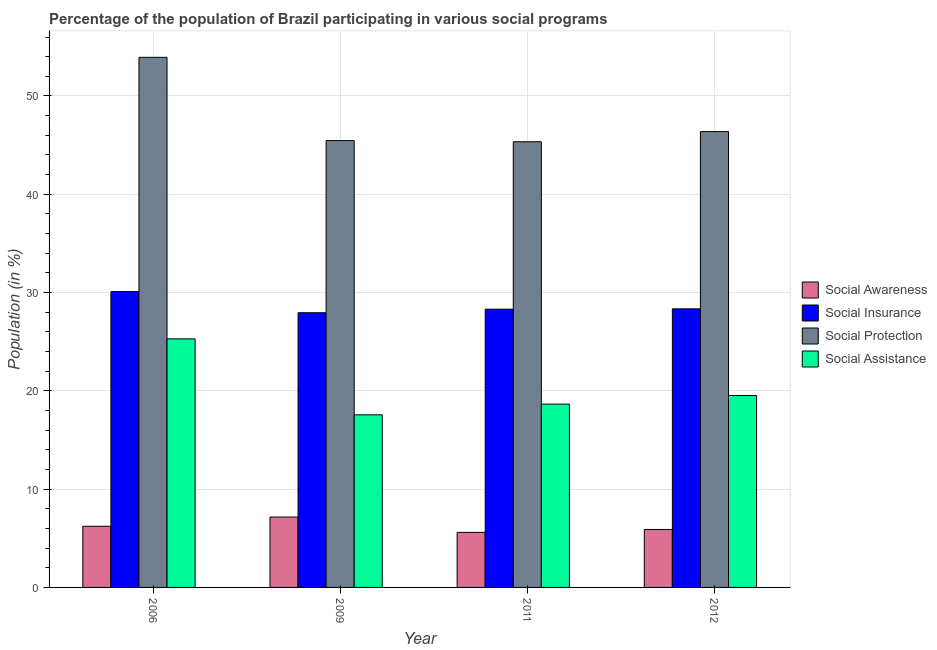Are the number of bars per tick equal to the number of legend labels?
Make the answer very short. Yes. How many bars are there on the 2nd tick from the left?
Your answer should be compact. 4. How many bars are there on the 3rd tick from the right?
Your answer should be very brief. 4. What is the participation of population in social assistance programs in 2011?
Offer a terse response. 18.65. Across all years, what is the maximum participation of population in social awareness programs?
Offer a very short reply. 7.16. Across all years, what is the minimum participation of population in social insurance programs?
Provide a succinct answer. 27.95. In which year was the participation of population in social insurance programs maximum?
Your answer should be compact. 2006. In which year was the participation of population in social insurance programs minimum?
Provide a succinct answer. 2009. What is the total participation of population in social assistance programs in the graph?
Offer a very short reply. 81.03. What is the difference between the participation of population in social protection programs in 2006 and that in 2009?
Provide a short and direct response. 8.47. What is the difference between the participation of population in social awareness programs in 2011 and the participation of population in social insurance programs in 2006?
Your answer should be very brief. -0.62. What is the average participation of population in social insurance programs per year?
Offer a terse response. 28.68. In the year 2012, what is the difference between the participation of population in social insurance programs and participation of population in social awareness programs?
Your answer should be very brief. 0. What is the ratio of the participation of population in social awareness programs in 2006 to that in 2009?
Provide a succinct answer. 0.87. Is the difference between the participation of population in social insurance programs in 2009 and 2011 greater than the difference between the participation of population in social awareness programs in 2009 and 2011?
Your answer should be very brief. No. What is the difference between the highest and the second highest participation of population in social assistance programs?
Make the answer very short. 5.76. What is the difference between the highest and the lowest participation of population in social assistance programs?
Provide a succinct answer. 7.73. In how many years, is the participation of population in social insurance programs greater than the average participation of population in social insurance programs taken over all years?
Make the answer very short. 1. Is it the case that in every year, the sum of the participation of population in social assistance programs and participation of population in social protection programs is greater than the sum of participation of population in social insurance programs and participation of population in social awareness programs?
Provide a succinct answer. No. What does the 4th bar from the left in 2006 represents?
Give a very brief answer. Social Assistance. What does the 3rd bar from the right in 2009 represents?
Make the answer very short. Social Insurance. Is it the case that in every year, the sum of the participation of population in social awareness programs and participation of population in social insurance programs is greater than the participation of population in social protection programs?
Make the answer very short. No. What is the difference between two consecutive major ticks on the Y-axis?
Provide a short and direct response. 10. Are the values on the major ticks of Y-axis written in scientific E-notation?
Provide a succinct answer. No. Does the graph contain any zero values?
Ensure brevity in your answer.  No. Where does the legend appear in the graph?
Ensure brevity in your answer.  Center right. What is the title of the graph?
Offer a terse response. Percentage of the population of Brazil participating in various social programs . What is the label or title of the Y-axis?
Ensure brevity in your answer.  Population (in %). What is the Population (in %) of Social Awareness in 2006?
Offer a terse response. 6.22. What is the Population (in %) in Social Insurance in 2006?
Offer a terse response. 30.1. What is the Population (in %) of Social Protection in 2006?
Your response must be concise. 53.93. What is the Population (in %) in Social Assistance in 2006?
Your answer should be compact. 25.29. What is the Population (in %) in Social Awareness in 2009?
Offer a very short reply. 7.16. What is the Population (in %) in Social Insurance in 2009?
Provide a short and direct response. 27.95. What is the Population (in %) in Social Protection in 2009?
Provide a succinct answer. 45.46. What is the Population (in %) of Social Assistance in 2009?
Ensure brevity in your answer.  17.56. What is the Population (in %) in Social Awareness in 2011?
Make the answer very short. 5.6. What is the Population (in %) in Social Insurance in 2011?
Your answer should be compact. 28.31. What is the Population (in %) of Social Protection in 2011?
Offer a very short reply. 45.34. What is the Population (in %) of Social Assistance in 2011?
Offer a very short reply. 18.65. What is the Population (in %) in Social Awareness in 2012?
Your answer should be very brief. 5.9. What is the Population (in %) in Social Insurance in 2012?
Offer a terse response. 28.34. What is the Population (in %) in Social Protection in 2012?
Provide a short and direct response. 46.38. What is the Population (in %) in Social Assistance in 2012?
Offer a very short reply. 19.53. Across all years, what is the maximum Population (in %) in Social Awareness?
Make the answer very short. 7.16. Across all years, what is the maximum Population (in %) in Social Insurance?
Your answer should be very brief. 30.1. Across all years, what is the maximum Population (in %) of Social Protection?
Keep it short and to the point. 53.93. Across all years, what is the maximum Population (in %) of Social Assistance?
Your response must be concise. 25.29. Across all years, what is the minimum Population (in %) in Social Awareness?
Your answer should be compact. 5.6. Across all years, what is the minimum Population (in %) in Social Insurance?
Provide a succinct answer. 27.95. Across all years, what is the minimum Population (in %) in Social Protection?
Provide a short and direct response. 45.34. Across all years, what is the minimum Population (in %) of Social Assistance?
Your answer should be very brief. 17.56. What is the total Population (in %) of Social Awareness in the graph?
Your response must be concise. 24.88. What is the total Population (in %) of Social Insurance in the graph?
Provide a succinct answer. 114.7. What is the total Population (in %) of Social Protection in the graph?
Provide a succinct answer. 191.11. What is the total Population (in %) of Social Assistance in the graph?
Ensure brevity in your answer.  81.03. What is the difference between the Population (in %) of Social Awareness in 2006 and that in 2009?
Offer a terse response. -0.94. What is the difference between the Population (in %) of Social Insurance in 2006 and that in 2009?
Your answer should be compact. 2.15. What is the difference between the Population (in %) of Social Protection in 2006 and that in 2009?
Keep it short and to the point. 8.47. What is the difference between the Population (in %) of Social Assistance in 2006 and that in 2009?
Provide a short and direct response. 7.73. What is the difference between the Population (in %) in Social Awareness in 2006 and that in 2011?
Keep it short and to the point. 0.62. What is the difference between the Population (in %) in Social Insurance in 2006 and that in 2011?
Make the answer very short. 1.79. What is the difference between the Population (in %) in Social Protection in 2006 and that in 2011?
Offer a terse response. 8.59. What is the difference between the Population (in %) of Social Assistance in 2006 and that in 2011?
Give a very brief answer. 6.64. What is the difference between the Population (in %) in Social Awareness in 2006 and that in 2012?
Provide a short and direct response. 0.32. What is the difference between the Population (in %) in Social Insurance in 2006 and that in 2012?
Your answer should be very brief. 1.76. What is the difference between the Population (in %) of Social Protection in 2006 and that in 2012?
Offer a very short reply. 7.56. What is the difference between the Population (in %) in Social Assistance in 2006 and that in 2012?
Give a very brief answer. 5.76. What is the difference between the Population (in %) of Social Awareness in 2009 and that in 2011?
Provide a short and direct response. 1.56. What is the difference between the Population (in %) of Social Insurance in 2009 and that in 2011?
Ensure brevity in your answer.  -0.36. What is the difference between the Population (in %) of Social Protection in 2009 and that in 2011?
Offer a very short reply. 0.12. What is the difference between the Population (in %) of Social Assistance in 2009 and that in 2011?
Offer a very short reply. -1.09. What is the difference between the Population (in %) in Social Awareness in 2009 and that in 2012?
Provide a succinct answer. 1.26. What is the difference between the Population (in %) of Social Insurance in 2009 and that in 2012?
Provide a short and direct response. -0.4. What is the difference between the Population (in %) in Social Protection in 2009 and that in 2012?
Provide a short and direct response. -0.92. What is the difference between the Population (in %) of Social Assistance in 2009 and that in 2012?
Your answer should be compact. -1.97. What is the difference between the Population (in %) in Social Awareness in 2011 and that in 2012?
Your response must be concise. -0.3. What is the difference between the Population (in %) of Social Insurance in 2011 and that in 2012?
Offer a terse response. -0.03. What is the difference between the Population (in %) of Social Protection in 2011 and that in 2012?
Keep it short and to the point. -1.03. What is the difference between the Population (in %) in Social Assistance in 2011 and that in 2012?
Make the answer very short. -0.88. What is the difference between the Population (in %) of Social Awareness in 2006 and the Population (in %) of Social Insurance in 2009?
Offer a very short reply. -21.73. What is the difference between the Population (in %) in Social Awareness in 2006 and the Population (in %) in Social Protection in 2009?
Give a very brief answer. -39.24. What is the difference between the Population (in %) in Social Awareness in 2006 and the Population (in %) in Social Assistance in 2009?
Provide a succinct answer. -11.34. What is the difference between the Population (in %) in Social Insurance in 2006 and the Population (in %) in Social Protection in 2009?
Make the answer very short. -15.36. What is the difference between the Population (in %) in Social Insurance in 2006 and the Population (in %) in Social Assistance in 2009?
Provide a short and direct response. 12.54. What is the difference between the Population (in %) in Social Protection in 2006 and the Population (in %) in Social Assistance in 2009?
Offer a very short reply. 36.37. What is the difference between the Population (in %) of Social Awareness in 2006 and the Population (in %) of Social Insurance in 2011?
Give a very brief answer. -22.09. What is the difference between the Population (in %) of Social Awareness in 2006 and the Population (in %) of Social Protection in 2011?
Your answer should be very brief. -39.12. What is the difference between the Population (in %) in Social Awareness in 2006 and the Population (in %) in Social Assistance in 2011?
Your response must be concise. -12.43. What is the difference between the Population (in %) in Social Insurance in 2006 and the Population (in %) in Social Protection in 2011?
Ensure brevity in your answer.  -15.24. What is the difference between the Population (in %) of Social Insurance in 2006 and the Population (in %) of Social Assistance in 2011?
Offer a terse response. 11.45. What is the difference between the Population (in %) in Social Protection in 2006 and the Population (in %) in Social Assistance in 2011?
Your answer should be compact. 35.28. What is the difference between the Population (in %) of Social Awareness in 2006 and the Population (in %) of Social Insurance in 2012?
Your answer should be very brief. -22.12. What is the difference between the Population (in %) of Social Awareness in 2006 and the Population (in %) of Social Protection in 2012?
Offer a terse response. -40.16. What is the difference between the Population (in %) in Social Awareness in 2006 and the Population (in %) in Social Assistance in 2012?
Give a very brief answer. -13.31. What is the difference between the Population (in %) in Social Insurance in 2006 and the Population (in %) in Social Protection in 2012?
Offer a very short reply. -16.28. What is the difference between the Population (in %) in Social Insurance in 2006 and the Population (in %) in Social Assistance in 2012?
Offer a very short reply. 10.57. What is the difference between the Population (in %) in Social Protection in 2006 and the Population (in %) in Social Assistance in 2012?
Make the answer very short. 34.4. What is the difference between the Population (in %) in Social Awareness in 2009 and the Population (in %) in Social Insurance in 2011?
Offer a very short reply. -21.15. What is the difference between the Population (in %) in Social Awareness in 2009 and the Population (in %) in Social Protection in 2011?
Provide a succinct answer. -38.18. What is the difference between the Population (in %) in Social Awareness in 2009 and the Population (in %) in Social Assistance in 2011?
Offer a very short reply. -11.49. What is the difference between the Population (in %) in Social Insurance in 2009 and the Population (in %) in Social Protection in 2011?
Your answer should be very brief. -17.4. What is the difference between the Population (in %) of Social Insurance in 2009 and the Population (in %) of Social Assistance in 2011?
Offer a terse response. 9.29. What is the difference between the Population (in %) in Social Protection in 2009 and the Population (in %) in Social Assistance in 2011?
Offer a terse response. 26.81. What is the difference between the Population (in %) of Social Awareness in 2009 and the Population (in %) of Social Insurance in 2012?
Your answer should be very brief. -21.18. What is the difference between the Population (in %) in Social Awareness in 2009 and the Population (in %) in Social Protection in 2012?
Give a very brief answer. -39.22. What is the difference between the Population (in %) in Social Awareness in 2009 and the Population (in %) in Social Assistance in 2012?
Provide a succinct answer. -12.37. What is the difference between the Population (in %) in Social Insurance in 2009 and the Population (in %) in Social Protection in 2012?
Provide a succinct answer. -18.43. What is the difference between the Population (in %) of Social Insurance in 2009 and the Population (in %) of Social Assistance in 2012?
Your response must be concise. 8.42. What is the difference between the Population (in %) in Social Protection in 2009 and the Population (in %) in Social Assistance in 2012?
Provide a short and direct response. 25.93. What is the difference between the Population (in %) in Social Awareness in 2011 and the Population (in %) in Social Insurance in 2012?
Keep it short and to the point. -22.74. What is the difference between the Population (in %) in Social Awareness in 2011 and the Population (in %) in Social Protection in 2012?
Provide a short and direct response. -40.77. What is the difference between the Population (in %) of Social Awareness in 2011 and the Population (in %) of Social Assistance in 2012?
Make the answer very short. -13.93. What is the difference between the Population (in %) in Social Insurance in 2011 and the Population (in %) in Social Protection in 2012?
Ensure brevity in your answer.  -18.07. What is the difference between the Population (in %) of Social Insurance in 2011 and the Population (in %) of Social Assistance in 2012?
Provide a succinct answer. 8.78. What is the difference between the Population (in %) of Social Protection in 2011 and the Population (in %) of Social Assistance in 2012?
Offer a terse response. 25.82. What is the average Population (in %) of Social Awareness per year?
Give a very brief answer. 6.22. What is the average Population (in %) in Social Insurance per year?
Give a very brief answer. 28.68. What is the average Population (in %) of Social Protection per year?
Ensure brevity in your answer.  47.78. What is the average Population (in %) of Social Assistance per year?
Ensure brevity in your answer.  20.26. In the year 2006, what is the difference between the Population (in %) in Social Awareness and Population (in %) in Social Insurance?
Your answer should be very brief. -23.88. In the year 2006, what is the difference between the Population (in %) in Social Awareness and Population (in %) in Social Protection?
Make the answer very short. -47.71. In the year 2006, what is the difference between the Population (in %) in Social Awareness and Population (in %) in Social Assistance?
Your response must be concise. -19.07. In the year 2006, what is the difference between the Population (in %) of Social Insurance and Population (in %) of Social Protection?
Your answer should be very brief. -23.83. In the year 2006, what is the difference between the Population (in %) in Social Insurance and Population (in %) in Social Assistance?
Give a very brief answer. 4.81. In the year 2006, what is the difference between the Population (in %) of Social Protection and Population (in %) of Social Assistance?
Provide a short and direct response. 28.64. In the year 2009, what is the difference between the Population (in %) of Social Awareness and Population (in %) of Social Insurance?
Keep it short and to the point. -20.79. In the year 2009, what is the difference between the Population (in %) in Social Awareness and Population (in %) in Social Protection?
Give a very brief answer. -38.3. In the year 2009, what is the difference between the Population (in %) in Social Awareness and Population (in %) in Social Assistance?
Provide a short and direct response. -10.4. In the year 2009, what is the difference between the Population (in %) in Social Insurance and Population (in %) in Social Protection?
Offer a very short reply. -17.51. In the year 2009, what is the difference between the Population (in %) in Social Insurance and Population (in %) in Social Assistance?
Provide a short and direct response. 10.39. In the year 2009, what is the difference between the Population (in %) of Social Protection and Population (in %) of Social Assistance?
Make the answer very short. 27.9. In the year 2011, what is the difference between the Population (in %) in Social Awareness and Population (in %) in Social Insurance?
Keep it short and to the point. -22.71. In the year 2011, what is the difference between the Population (in %) in Social Awareness and Population (in %) in Social Protection?
Make the answer very short. -39.74. In the year 2011, what is the difference between the Population (in %) in Social Awareness and Population (in %) in Social Assistance?
Offer a terse response. -13.05. In the year 2011, what is the difference between the Population (in %) in Social Insurance and Population (in %) in Social Protection?
Give a very brief answer. -17.03. In the year 2011, what is the difference between the Population (in %) of Social Insurance and Population (in %) of Social Assistance?
Make the answer very short. 9.66. In the year 2011, what is the difference between the Population (in %) of Social Protection and Population (in %) of Social Assistance?
Your answer should be very brief. 26.69. In the year 2012, what is the difference between the Population (in %) of Social Awareness and Population (in %) of Social Insurance?
Give a very brief answer. -22.45. In the year 2012, what is the difference between the Population (in %) in Social Awareness and Population (in %) in Social Protection?
Offer a very short reply. -40.48. In the year 2012, what is the difference between the Population (in %) in Social Awareness and Population (in %) in Social Assistance?
Provide a succinct answer. -13.63. In the year 2012, what is the difference between the Population (in %) of Social Insurance and Population (in %) of Social Protection?
Your answer should be compact. -18.03. In the year 2012, what is the difference between the Population (in %) of Social Insurance and Population (in %) of Social Assistance?
Ensure brevity in your answer.  8.82. In the year 2012, what is the difference between the Population (in %) of Social Protection and Population (in %) of Social Assistance?
Ensure brevity in your answer.  26.85. What is the ratio of the Population (in %) of Social Awareness in 2006 to that in 2009?
Offer a terse response. 0.87. What is the ratio of the Population (in %) in Social Insurance in 2006 to that in 2009?
Provide a succinct answer. 1.08. What is the ratio of the Population (in %) of Social Protection in 2006 to that in 2009?
Your answer should be very brief. 1.19. What is the ratio of the Population (in %) of Social Assistance in 2006 to that in 2009?
Offer a very short reply. 1.44. What is the ratio of the Population (in %) in Social Awareness in 2006 to that in 2011?
Provide a short and direct response. 1.11. What is the ratio of the Population (in %) in Social Insurance in 2006 to that in 2011?
Keep it short and to the point. 1.06. What is the ratio of the Population (in %) of Social Protection in 2006 to that in 2011?
Offer a terse response. 1.19. What is the ratio of the Population (in %) of Social Assistance in 2006 to that in 2011?
Provide a succinct answer. 1.36. What is the ratio of the Population (in %) of Social Awareness in 2006 to that in 2012?
Ensure brevity in your answer.  1.05. What is the ratio of the Population (in %) in Social Insurance in 2006 to that in 2012?
Your answer should be very brief. 1.06. What is the ratio of the Population (in %) in Social Protection in 2006 to that in 2012?
Your answer should be compact. 1.16. What is the ratio of the Population (in %) of Social Assistance in 2006 to that in 2012?
Provide a succinct answer. 1.29. What is the ratio of the Population (in %) in Social Awareness in 2009 to that in 2011?
Provide a succinct answer. 1.28. What is the ratio of the Population (in %) of Social Insurance in 2009 to that in 2011?
Your response must be concise. 0.99. What is the ratio of the Population (in %) of Social Protection in 2009 to that in 2011?
Ensure brevity in your answer.  1. What is the ratio of the Population (in %) of Social Assistance in 2009 to that in 2011?
Your answer should be very brief. 0.94. What is the ratio of the Population (in %) in Social Awareness in 2009 to that in 2012?
Your response must be concise. 1.21. What is the ratio of the Population (in %) in Social Insurance in 2009 to that in 2012?
Ensure brevity in your answer.  0.99. What is the ratio of the Population (in %) of Social Protection in 2009 to that in 2012?
Your answer should be compact. 0.98. What is the ratio of the Population (in %) of Social Assistance in 2009 to that in 2012?
Offer a terse response. 0.9. What is the ratio of the Population (in %) of Social Awareness in 2011 to that in 2012?
Your answer should be very brief. 0.95. What is the ratio of the Population (in %) in Social Insurance in 2011 to that in 2012?
Give a very brief answer. 1. What is the ratio of the Population (in %) in Social Protection in 2011 to that in 2012?
Provide a succinct answer. 0.98. What is the ratio of the Population (in %) in Social Assistance in 2011 to that in 2012?
Keep it short and to the point. 0.96. What is the difference between the highest and the second highest Population (in %) of Social Awareness?
Your answer should be compact. 0.94. What is the difference between the highest and the second highest Population (in %) in Social Insurance?
Offer a very short reply. 1.76. What is the difference between the highest and the second highest Population (in %) in Social Protection?
Your response must be concise. 7.56. What is the difference between the highest and the second highest Population (in %) of Social Assistance?
Your answer should be very brief. 5.76. What is the difference between the highest and the lowest Population (in %) in Social Awareness?
Keep it short and to the point. 1.56. What is the difference between the highest and the lowest Population (in %) in Social Insurance?
Keep it short and to the point. 2.15. What is the difference between the highest and the lowest Population (in %) of Social Protection?
Offer a terse response. 8.59. What is the difference between the highest and the lowest Population (in %) of Social Assistance?
Make the answer very short. 7.73. 